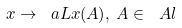<formula> <loc_0><loc_0><loc_500><loc_500>\L x \rightarrow \ a L x ( A ) , \, A \in \ A l</formula> 